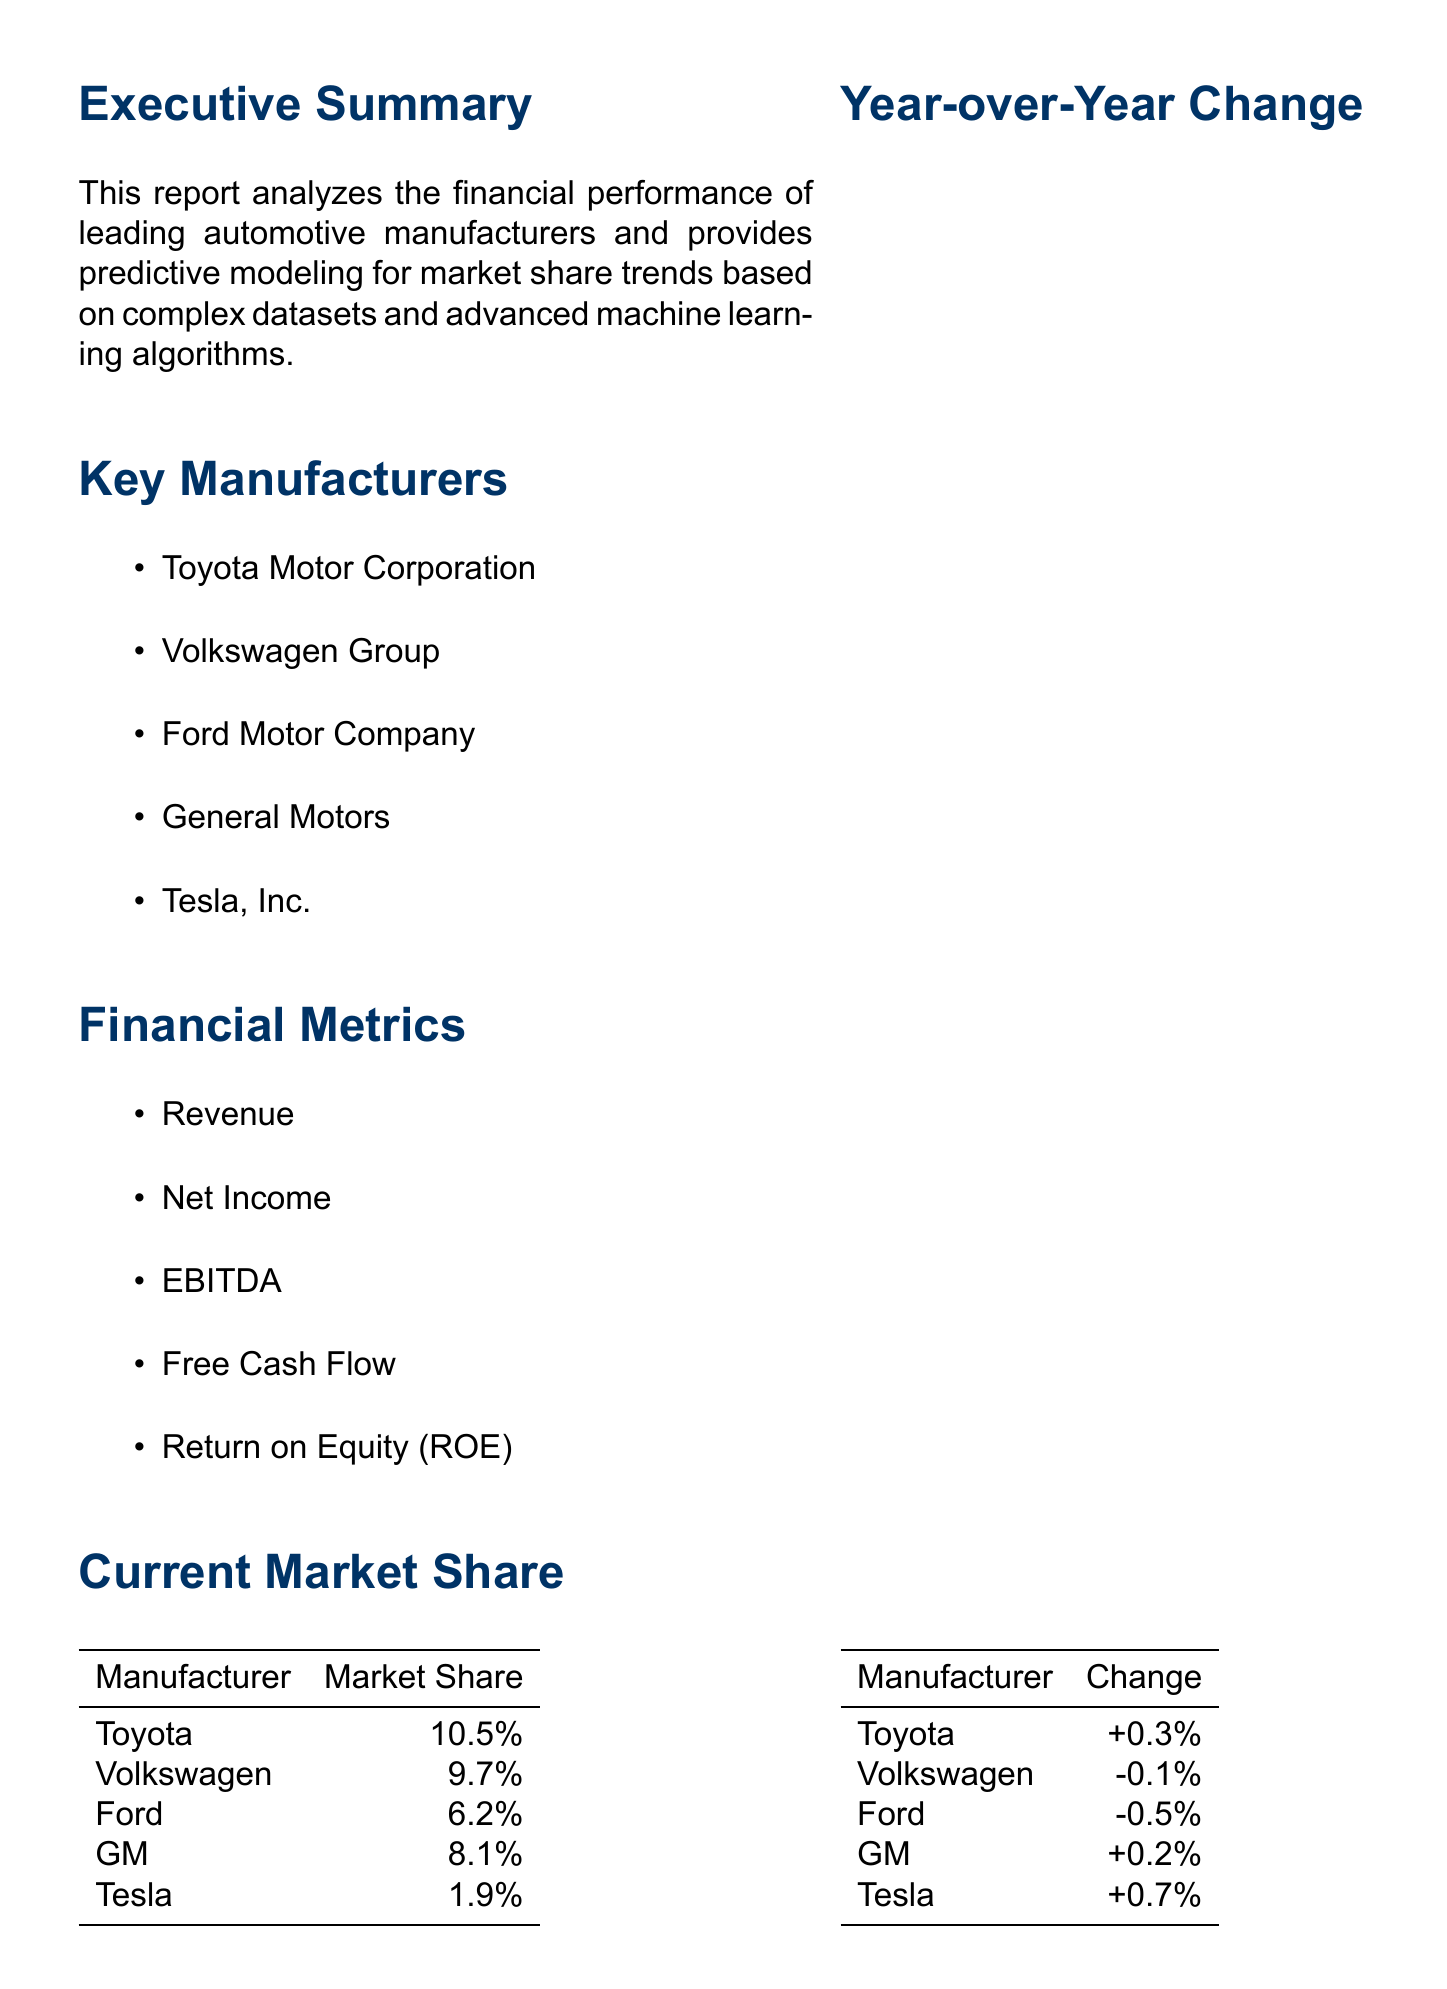What is the current market share of Tesla? The current market share of Tesla is specified in the document as 1.9%.
Answer: 1.9% Which manufacturer has the highest year-over-year change? The year-over-year change indicates how each manufacturer's market share has increased or decreased compared to the previous year. Tesla has the highest change at +0.7%.
Answer: Tesla What is the 6-month forecast for Ford's market share? The document provides a 6-month forecast for each manufacturer, which shows Ford's market share will be 6.0%.
Answer: 6.0% Name one key trend mentioned in the report. The report lists key trends affecting the automotive market, including accelerated EV market growth.
Answer: Accelerated EV market growth Which two manufacturers are positioned for modest growth according to the conclusion? The conclusion summarizes positioning for growth, specifically mentioning Toyota and GM.
Answer: Toyota and GM What financial metric is NOT listed in the document? The document lists various financial metrics and one key metric not mentioned is earnings per share.
Answer: Earnings per share Which manufacturer is predicted to lose market share in the next 6 months? The market share forecast for the next 6 months predicts Volkswagen's market share to decrease to 9.6%.
Answer: Volkswagen What is the predictive model feature related to consumer behavior? The report outlines predictive model features that include understanding consumer behaviors, specifically noted as consumer sentiment analysis.
Answer: Consumer sentiment analysis 